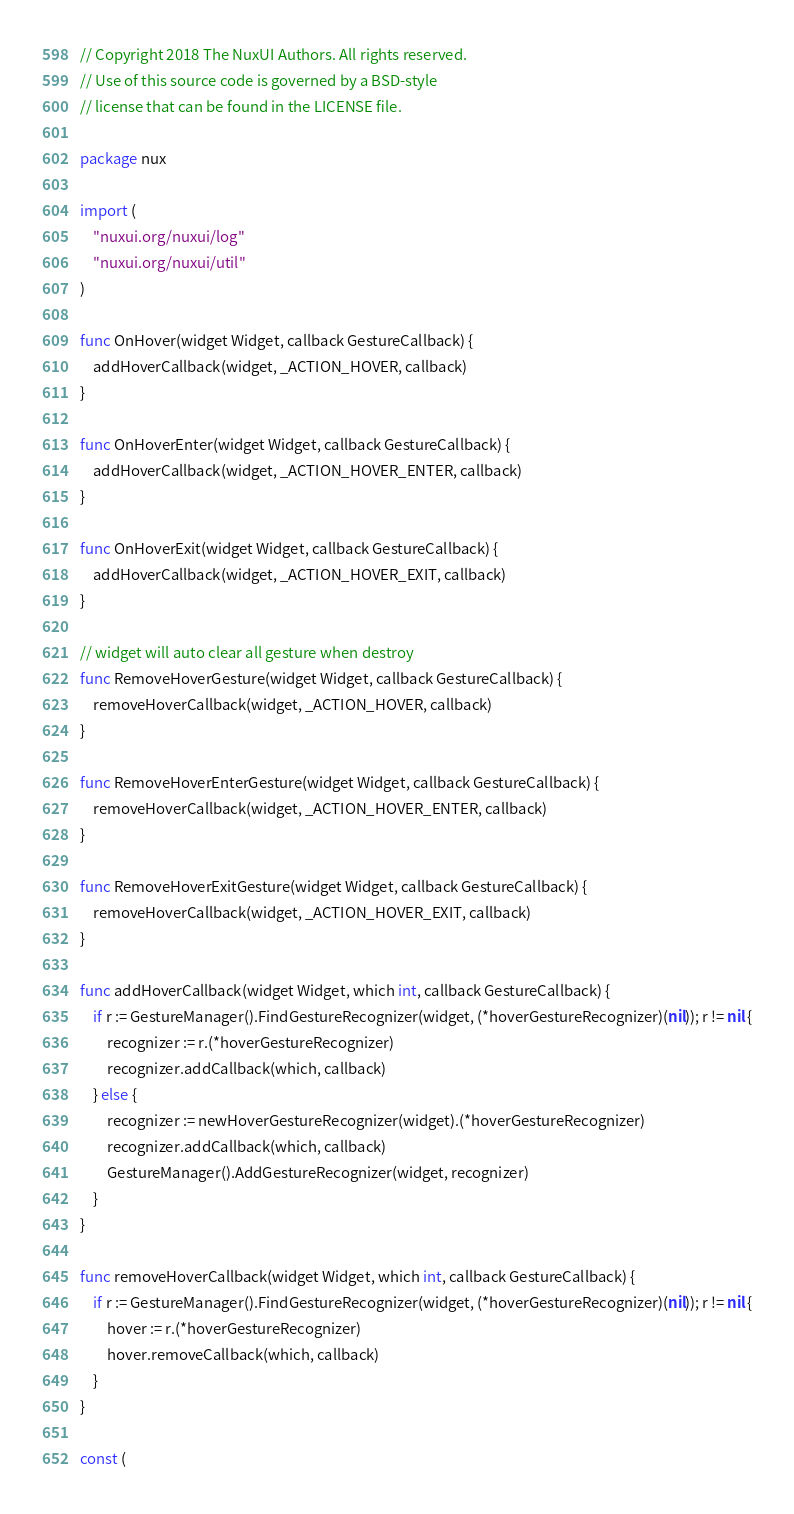<code> <loc_0><loc_0><loc_500><loc_500><_Go_>// Copyright 2018 The NuxUI Authors. All rights reserved.
// Use of this source code is governed by a BSD-style
// license that can be found in the LICENSE file.

package nux

import (
	"nuxui.org/nuxui/log"
	"nuxui.org/nuxui/util"
)

func OnHover(widget Widget, callback GestureCallback) {
	addHoverCallback(widget, _ACTION_HOVER, callback)
}

func OnHoverEnter(widget Widget, callback GestureCallback) {
	addHoverCallback(widget, _ACTION_HOVER_ENTER, callback)
}

func OnHoverExit(widget Widget, callback GestureCallback) {
	addHoverCallback(widget, _ACTION_HOVER_EXIT, callback)
}

// widget will auto clear all gesture when destroy
func RemoveHoverGesture(widget Widget, callback GestureCallback) {
	removeHoverCallback(widget, _ACTION_HOVER, callback)
}

func RemoveHoverEnterGesture(widget Widget, callback GestureCallback) {
	removeHoverCallback(widget, _ACTION_HOVER_ENTER, callback)
}

func RemoveHoverExitGesture(widget Widget, callback GestureCallback) {
	removeHoverCallback(widget, _ACTION_HOVER_EXIT, callback)
}

func addHoverCallback(widget Widget, which int, callback GestureCallback) {
	if r := GestureManager().FindGestureRecognizer(widget, (*hoverGestureRecognizer)(nil)); r != nil {
		recognizer := r.(*hoverGestureRecognizer)
		recognizer.addCallback(which, callback)
	} else {
		recognizer := newHoverGestureRecognizer(widget).(*hoverGestureRecognizer)
		recognizer.addCallback(which, callback)
		GestureManager().AddGestureRecognizer(widget, recognizer)
	}
}

func removeHoverCallback(widget Widget, which int, callback GestureCallback) {
	if r := GestureManager().FindGestureRecognizer(widget, (*hoverGestureRecognizer)(nil)); r != nil {
		hover := r.(*hoverGestureRecognizer)
		hover.removeCallback(which, callback)
	}
}

const (</code> 